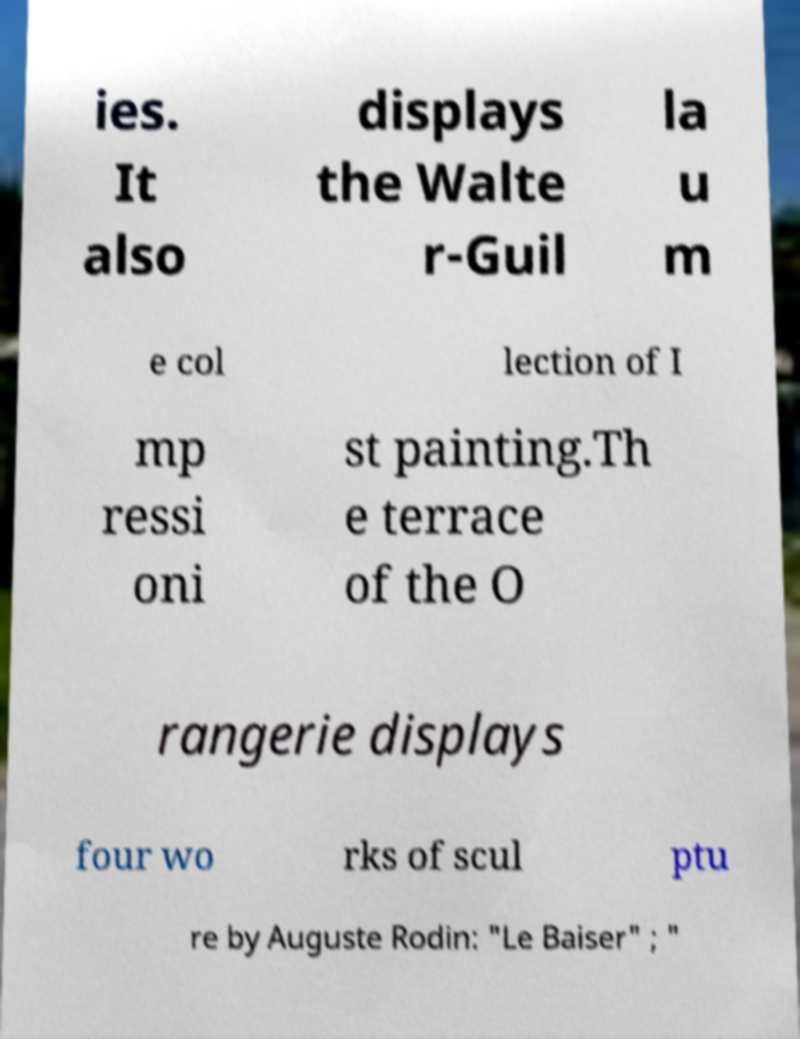Could you extract and type out the text from this image? ies. It also displays the Walte r-Guil la u m e col lection of I mp ressi oni st painting.Th e terrace of the O rangerie displays four wo rks of scul ptu re by Auguste Rodin: "Le Baiser" ; " 